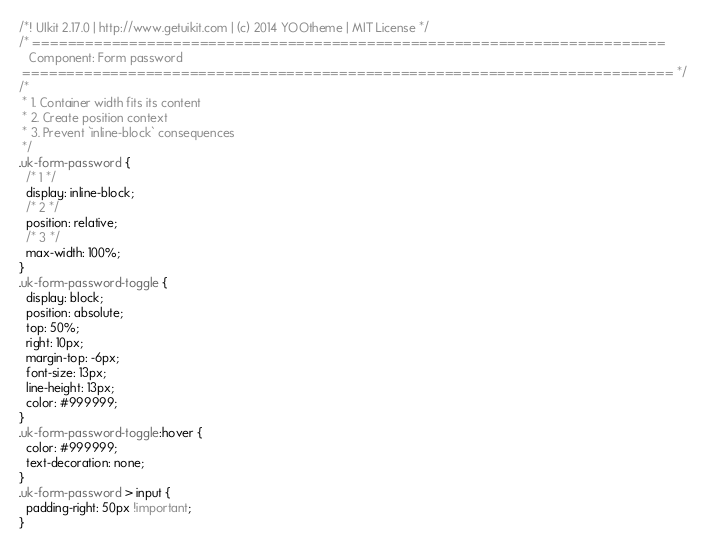Convert code to text. <code><loc_0><loc_0><loc_500><loc_500><_CSS_>/*! UIkit 2.17.0 | http://www.getuikit.com | (c) 2014 YOOtheme | MIT License */
/* ========================================================================
   Component: Form password
 ========================================================================== */
/*
 * 1. Container width fits its content
 * 2. Create position context
 * 3. Prevent `inline-block` consequences
 */
.uk-form-password {
  /* 1 */
  display: inline-block;
  /* 2 */
  position: relative;
  /* 3 */
  max-width: 100%;
}
.uk-form-password-toggle {
  display: block;
  position: absolute;
  top: 50%;
  right: 10px;
  margin-top: -6px;
  font-size: 13px;
  line-height: 13px;
  color: #999999;
}
.uk-form-password-toggle:hover {
  color: #999999;
  text-decoration: none;
}
.uk-form-password > input {
  padding-right: 50px !important;
}
</code> 